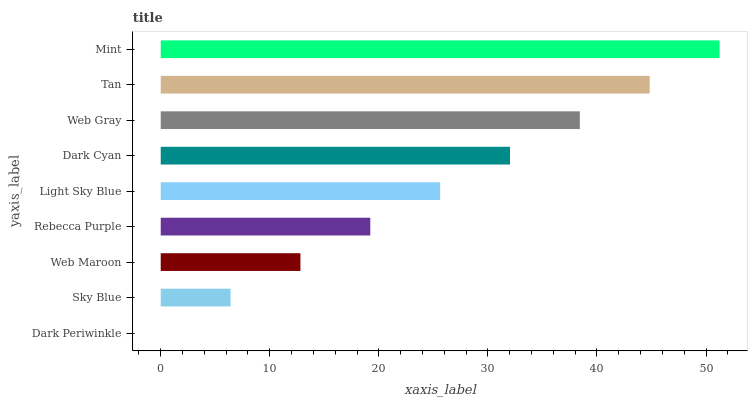Is Dark Periwinkle the minimum?
Answer yes or no. Yes. Is Mint the maximum?
Answer yes or no. Yes. Is Sky Blue the minimum?
Answer yes or no. No. Is Sky Blue the maximum?
Answer yes or no. No. Is Sky Blue greater than Dark Periwinkle?
Answer yes or no. Yes. Is Dark Periwinkle less than Sky Blue?
Answer yes or no. Yes. Is Dark Periwinkle greater than Sky Blue?
Answer yes or no. No. Is Sky Blue less than Dark Periwinkle?
Answer yes or no. No. Is Light Sky Blue the high median?
Answer yes or no. Yes. Is Light Sky Blue the low median?
Answer yes or no. Yes. Is Mint the high median?
Answer yes or no. No. Is Rebecca Purple the low median?
Answer yes or no. No. 